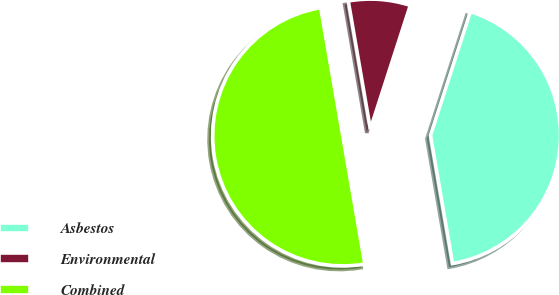<chart> <loc_0><loc_0><loc_500><loc_500><pie_chart><fcel>Asbestos<fcel>Environmental<fcel>Combined<nl><fcel>42.32%<fcel>7.68%<fcel>50.0%<nl></chart> 